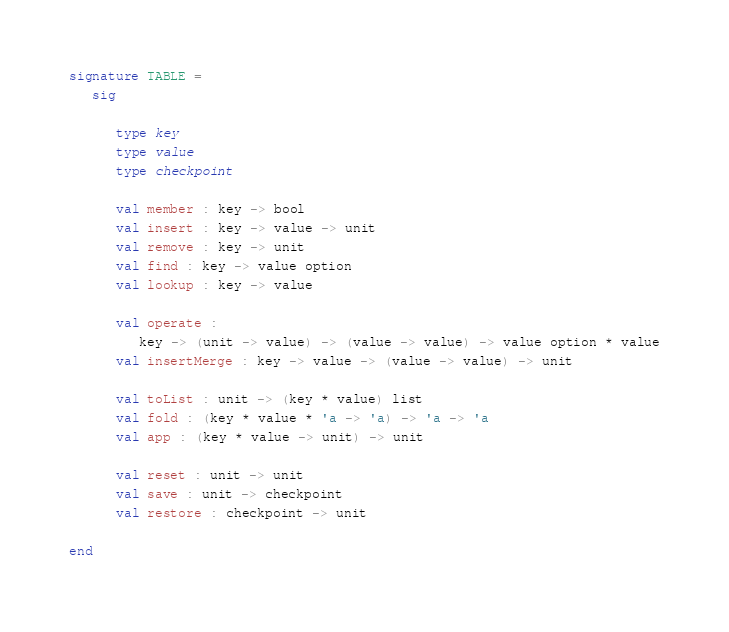<code> <loc_0><loc_0><loc_500><loc_500><_SML_>
signature TABLE = 
   sig
 
      type key
      type value
      type checkpoint
      
      val member : key -> bool
      val insert : key -> value -> unit
      val remove : key -> unit
      val find : key -> value option
      val lookup : key -> value

      val operate : 
         key -> (unit -> value) -> (value -> value) -> value option * value
      val insertMerge : key -> value -> (value -> value) -> unit

      val toList : unit -> (key * value) list
      val fold : (key * value * 'a -> 'a) -> 'a -> 'a 
      val app : (key * value -> unit) -> unit

      val reset : unit -> unit
      val save : unit -> checkpoint
      val restore : checkpoint -> unit

end
</code> 